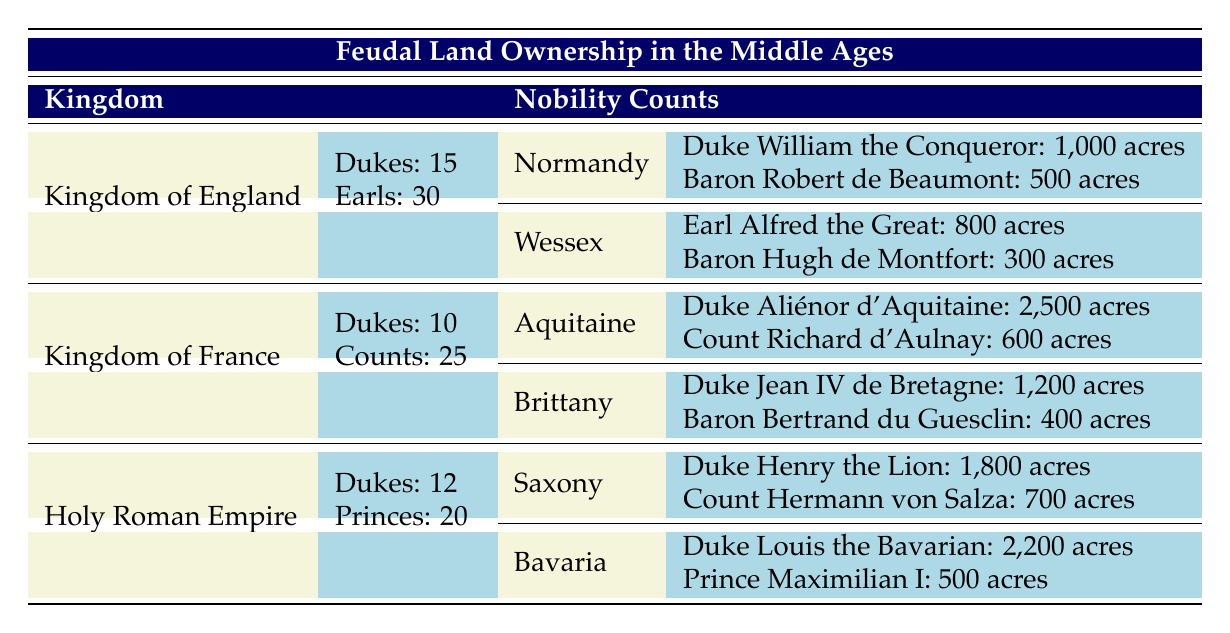What is the total number of Barons in the Kingdom of England? The table states there are 120 Barons in the Kingdom of England listed under the nobility counts.
Answer: 120 Which region in the Kingdom of France has the largest land ownership? Comparing the land areas, Aquitaine has 2,500 acres owned by Duke Aliénor d'Aquitaine, while no other region in France surpasses this amount.
Answer: Aquitaine How much land does Duke William the Conqueror own compared to Baron Hugh de Montfort? Duke William the Conqueror owns 1,000 acres, while Baron Hugh de Montfort owns 300 acres. The difference in ownership is 1,000 acres - 300 acres = 700 acres.
Answer: 700 acres How many Dukes are there in the Holy Roman Empire? The table indicates there are 12 Dukes in the Holy Roman Empire, which is explicitly stated in the nobility counts section.
Answer: 12 Is the total land ownership in Aquitaine greater than that in Normandy? In Aquitaine, the total land ownership is 2,500 acres (Duke Aliénor d'Aquitaine) + 600 acres (Count Richard d'Aulnay) = 3,100 acres. In Normandy, it is 1,000 acres (Duke William the Conqueror) + 500 acres (Baron Robert de Beaumont) = 1,500 acres. Thus, 3,100 acres is greater than 1,500 acres.
Answer: Yes What is the average land ownership of counts in the Kingdom of France? There are 25 Counts in the Kingdom of France. The land ownership is 600 acres for Count Richard d'Aulnay. Since there’s only one Count listed, the average ownership is simply 600 acres / 1 = 600 acres.
Answer: 600 acres Which title owns the largest land area in Bavaria? Duke Louis the Bavarian owns 2,200 acres, while Prince Maximilian I owns 500 acres. Therefore, Duke Louis the Bavarian has the largest land area ownership in Bavaria.
Answer: Duke Louis the Bavarian How many total acres do the Barons in the Kingdom of France own? In the Kingdom of France, the total acreage owned by Barons is calculated as follows: Baron Bertrand du Guesclin has 400 acres. There are 150 Barons total, but we can only see one’s acreage in the table. Thus, we cannot provide a complete answer without additional data on others.
Answer: Not determinable from given data What is the total land owned by nobility in Wessex? In Wessex, land ownership totals 800 acres for Earl Alfred the Great and 300 acres for Baron Hugh de Montfort. Adding these up gives 800 + 300 = 1,100 acres of total land owned by nobility in Wessex.
Answer: 1,100 acres 